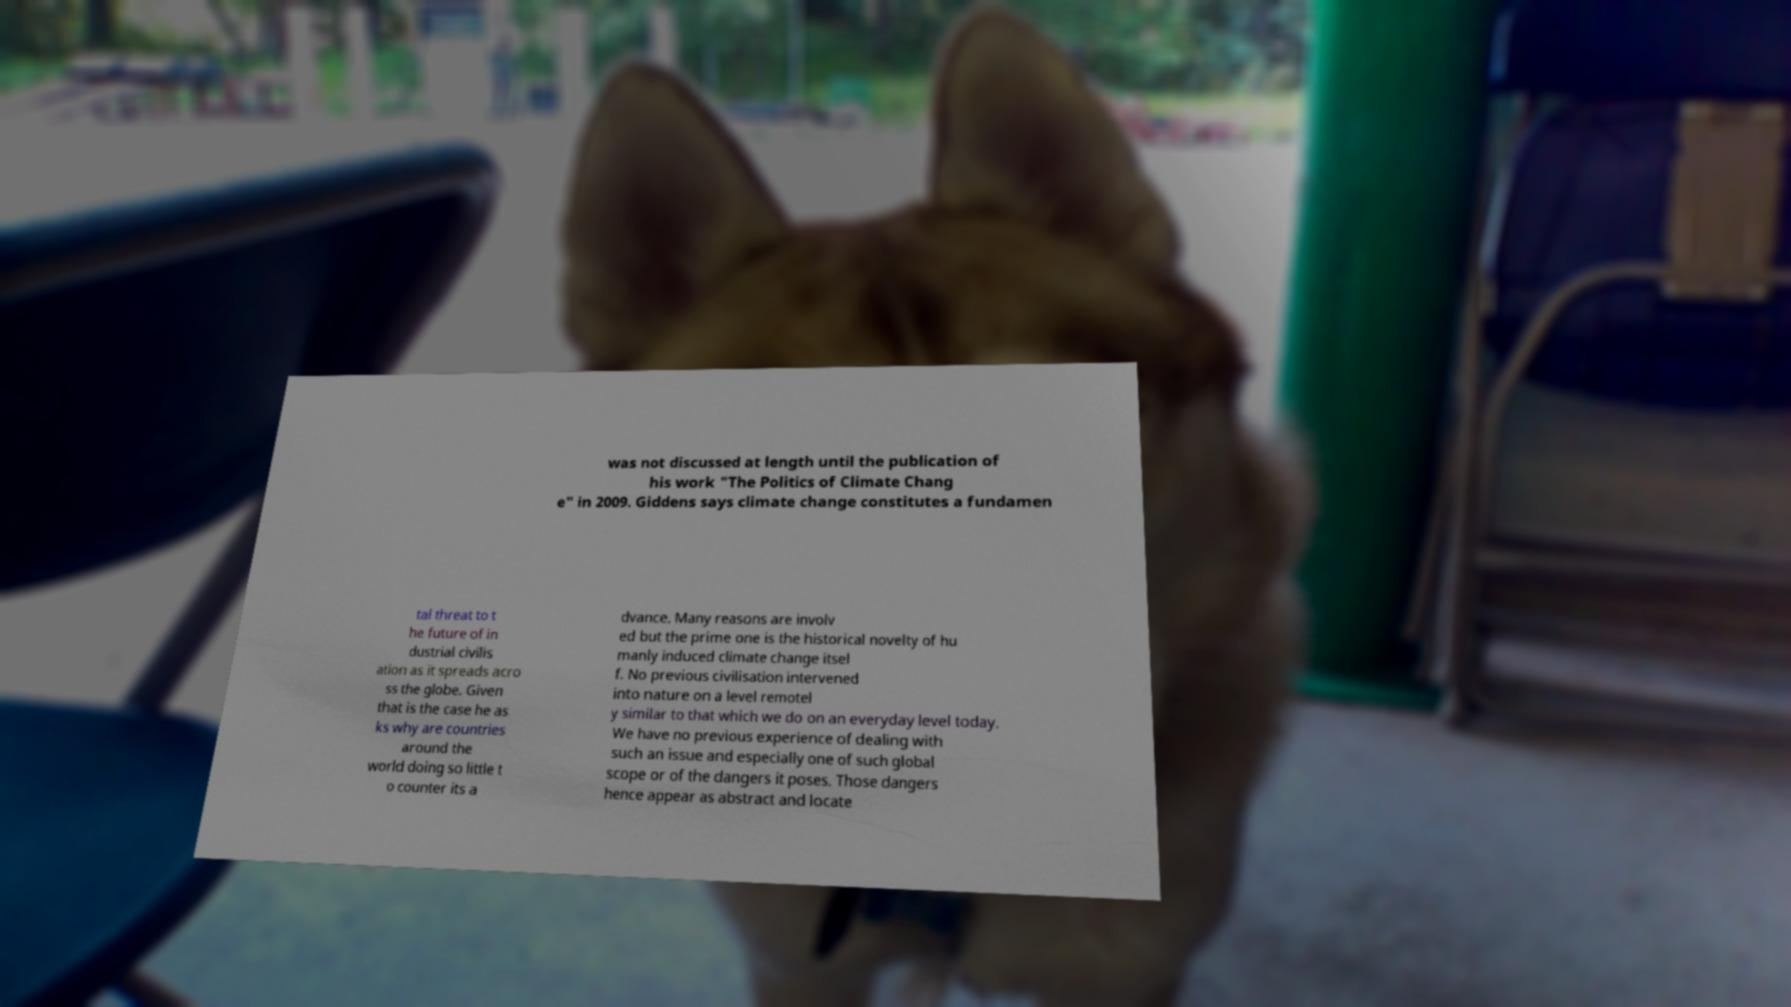Could you assist in decoding the text presented in this image and type it out clearly? was not discussed at length until the publication of his work "The Politics of Climate Chang e" in 2009. Giddens says climate change constitutes a fundamen tal threat to t he future of in dustrial civilis ation as it spreads acro ss the globe. Given that is the case he as ks why are countries around the world doing so little t o counter its a dvance. Many reasons are involv ed but the prime one is the historical novelty of hu manly induced climate change itsel f. No previous civilisation intervened into nature on a level remotel y similar to that which we do on an everyday level today. We have no previous experience of dealing with such an issue and especially one of such global scope or of the dangers it poses. Those dangers hence appear as abstract and locate 